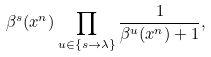Convert formula to latex. <formula><loc_0><loc_0><loc_500><loc_500>\beta ^ { s } ( x ^ { n } ) \prod _ { u \in \{ s \to \lambda \} } \frac { 1 } { \beta ^ { u } ( x ^ { n } ) + 1 } ,</formula> 